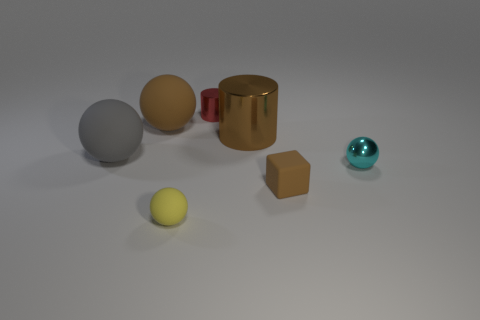How many small cyan shiny spheres are in front of the small yellow thing?
Provide a succinct answer. 0. Is there another small object that has the same material as the small cyan thing?
Your answer should be compact. Yes. There is a red cylinder that is the same size as the brown rubber cube; what is it made of?
Give a very brief answer. Metal. Is the small red object made of the same material as the big gray ball?
Ensure brevity in your answer.  No. How many things are tiny shiny cylinders or small purple cylinders?
Your answer should be compact. 1. There is a cyan metal object that is in front of the small cylinder; what is its shape?
Keep it short and to the point. Sphere. What color is the big sphere that is the same material as the big gray thing?
Give a very brief answer. Brown. What material is the other tiny object that is the same shape as the brown metallic object?
Make the answer very short. Metal. What is the shape of the red metal thing?
Offer a terse response. Cylinder. There is a object that is both to the left of the small yellow rubber ball and behind the brown metal thing; what is its material?
Give a very brief answer. Rubber. 